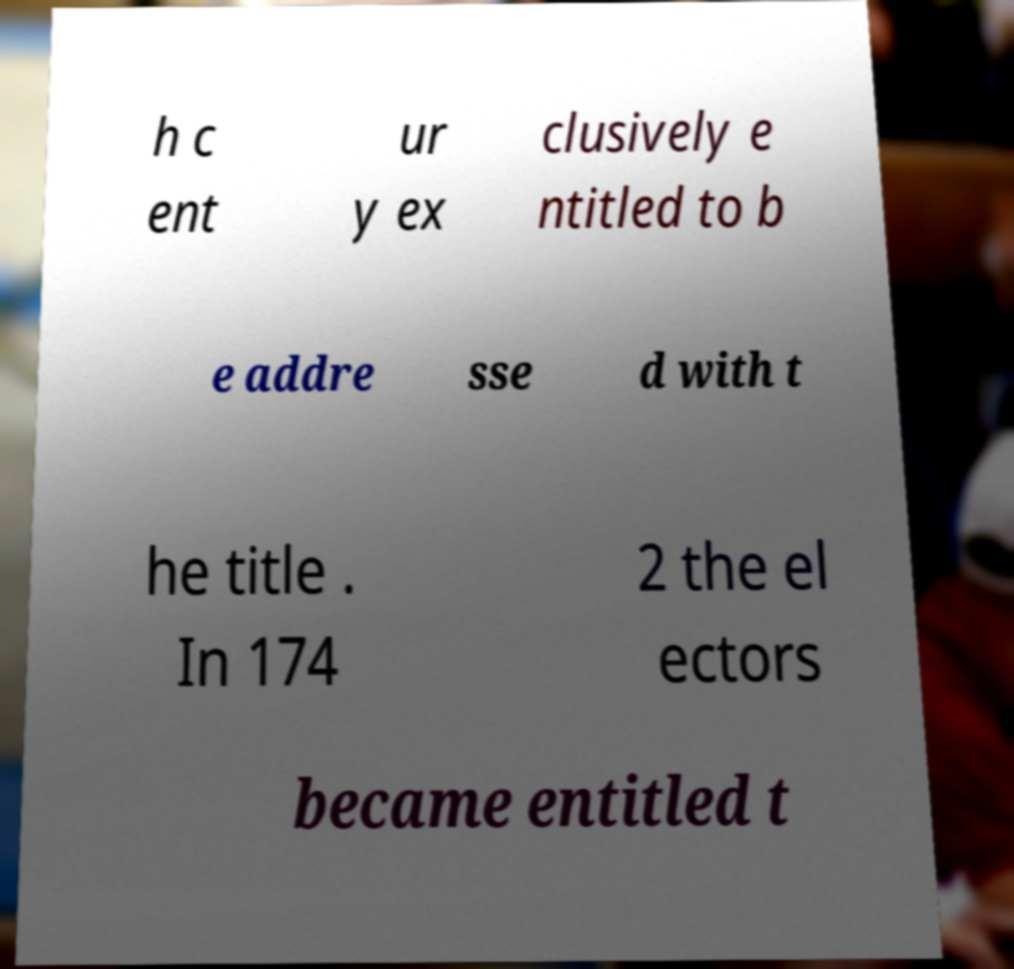Can you accurately transcribe the text from the provided image for me? h c ent ur y ex clusively e ntitled to b e addre sse d with t he title . In 174 2 the el ectors became entitled t 